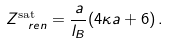<formula> <loc_0><loc_0><loc_500><loc_500>Z _ { \ r e n } ^ { \text {sat} } = \frac { a } { l _ { B } } ( 4 \kappa a + 6 ) \, .</formula> 